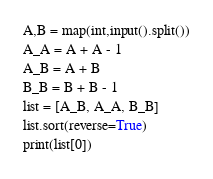Convert code to text. <code><loc_0><loc_0><loc_500><loc_500><_Python_>A,B = map(int,input().split())
A_A = A + A - 1
A_B = A + B
B_B = B + B - 1
list = [A_B, A_A, B_B]
list.sort(reverse=True)
print(list[0])
</code> 